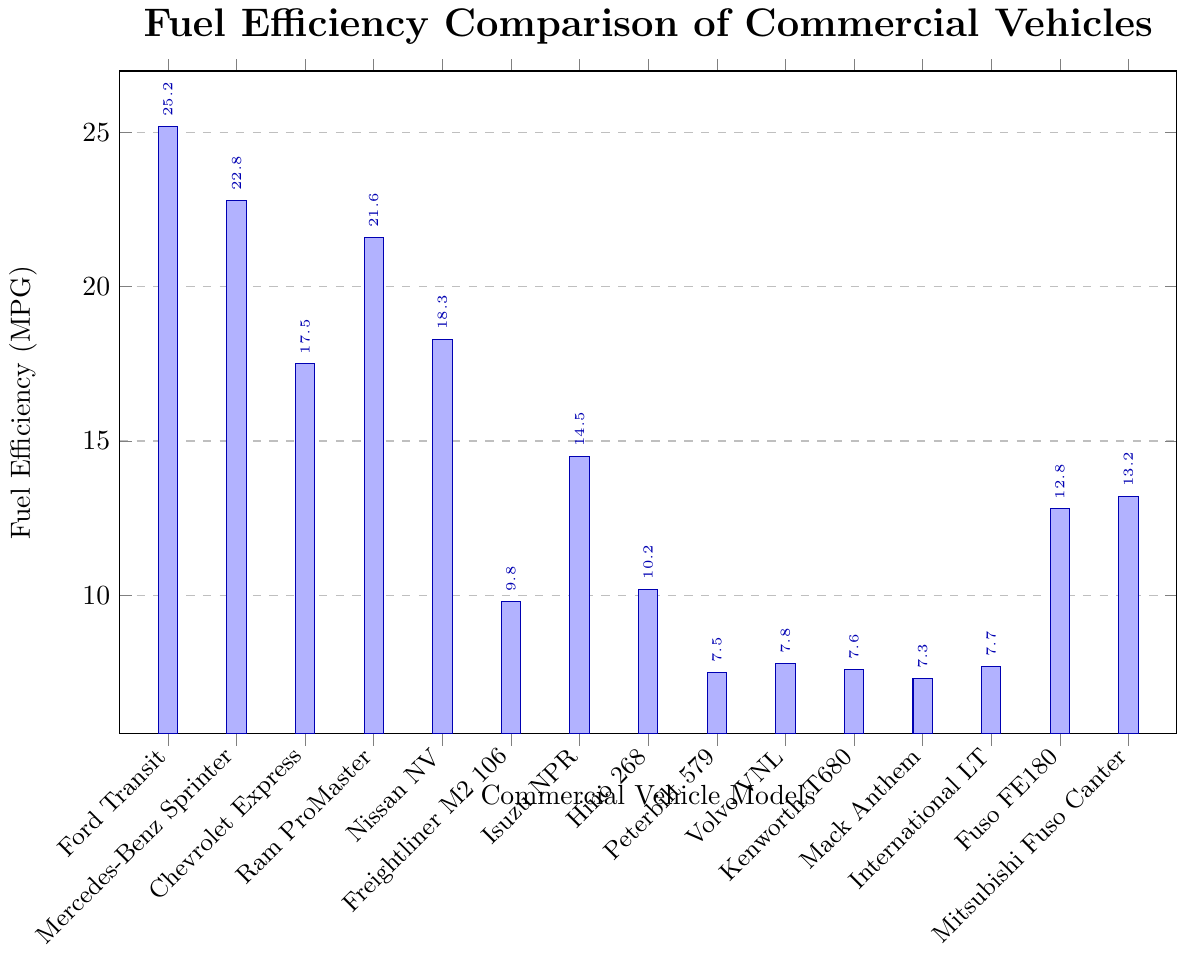What is the fuel efficiency of the Ford Transit? To find the fuel efficiency of the Ford Transit, look at the height of the bar corresponding to the Ford Transit in the bar chart. It's labeled with the number.
Answer: 25.2 MPG Which vehicle model has the lowest fuel efficiency? To determine the vehicle with the lowest fuel efficiency, find the shortest bar in the chart. The shortest bar represents the Mack Anthem, labeled with its fuel efficiency.
Answer: Mack Anthem (7.3 MPG) How much higher is the fuel efficiency of the Ford Transit compared to the Chevrolet Express? First, find the fuel efficiency of both the Ford Transit and Chevrolet Express from the chart. The Ford Transit is 25.2 MPG and the Chevrolet Express is 17.5 MPG. Subtract the fuel efficiency of the Chevrolet Express from that of the Ford Transit: 25.2 - 17.5 = 7.7.
Answer: 7.7 MPG What is the average fuel efficiency of the vehicles with the three lowest fuel efficiencies? Identify the three vehicles with the lowest efficiencies: Mack Anthem (7.3), Peterbilt 579 (7.5), and Kenworth T680 (7.6). Add their fuel efficiencies and divide by 3: (7.3 + 7.5 + 7.6) / 3 = 7.47.
Answer: 7.47 MPG Which vehicle category, those with fuel efficiency above 20 MPG or those below 20 MPG, has a greater number of models? Count the number of vehicle models above and below 20 MPG by checking each bar. Models above 20 MPG: Ford Transit, Mercedes-Benz Sprinter, Ram ProMaster (3 models). Models below 20 MPG: Chevrolet Express, Nissan NV, Freightliner M2 106, Isuzu NPR, Hino 268, Peterbilt 579, Volvo VNL, Kenworth T680, Mack Anthem, International LT, Fuso FE180, Mitsubishi Fuso Canter (12 models). Compare the counts.
Answer: Below 20 MPG (12 models) What is the range of fuel efficiencies across all vehicle models? Identify the highest and lowest fuel efficiencies from the bar chart. The highest is Ford Transit at 25.2 MPG and the lowest is Mack Anthem at 7.3 MPG. Subtract the lowest from the highest: 25.2 - 7.3 = 17.9.
Answer: 17.9 MPG Which vehicle model has a fuel efficiency closest to the average fuel efficiency of all models? First, calculate the average: sum all fuel efficiencies and divide by the number of models ((25.2 + 22.8 + 17.5 + 21.6 + 18.3 + 9.8 + 14.5 + 10.2 + 7.5 + 7.8 + 7.6 + 7.3 + 7.7 + 12.8 + 13.2) / 15 = 14.3). Then find the model with the closest value to this average.
Answer: Isuzu NPR (14.5 MPG) How does the fuel efficiency of the Nissan NV compare to the average fuel efficiency of all models? Calculate the average fuel efficiency as before (14.3 MPG). The Nissan NV has an efficiency of 18.3 MPG. Compare the two values: 18.3 is higher than 14.3.
Answer: Above average Which model among the Freightliner M2 106, Hino 268, and Isuzu NPR has the highest fuel efficiency? Compare the fuel efficiencies of the three models: Freightliner M2 106 (9.8), Hino 268 (10.2), and Isuzu NPR (14.5). The highest value among them is that of the Isuzu NPR.
Answer: Isuzu NPR Is there a significant difference in fuel efficiency between the highest and lowest models greater than 15 MPG? Identify the highest (Ford Transit, 25.2) and lowest (Mack Anthem, 7.3). Calculate the difference: 25.2 - 7.3 = 17.9. Compare it to 15 MPG.
Answer: Yes (17.9 MPG) 